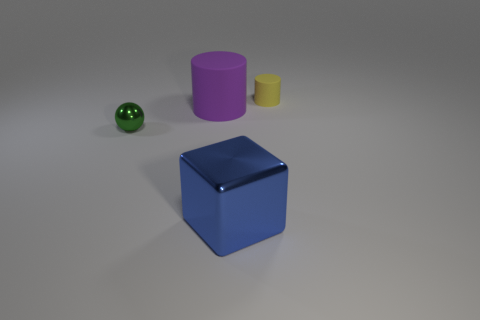What is the texture of the objects, and are there any reflections visible? The objects in the image display a variety of textures, from the smooth, reflective surface of the green sphere and blue cube to the more matte appearance of the cylinders. The lighting creates subtle reflections on the objects, particularly noticeable on the shiny sphere and cube. 